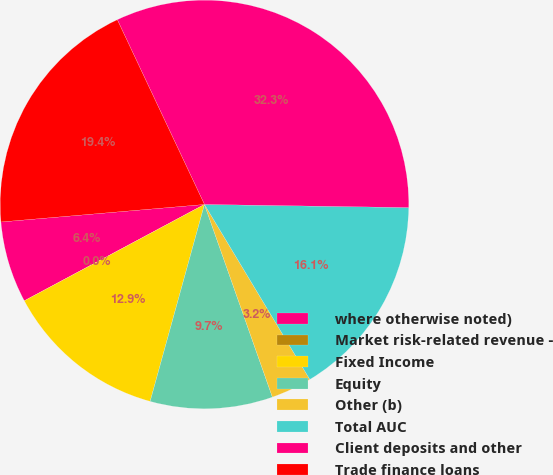Convert chart to OTSL. <chart><loc_0><loc_0><loc_500><loc_500><pie_chart><fcel>where otherwise noted)<fcel>Market risk-related revenue -<fcel>Fixed Income<fcel>Equity<fcel>Other (b)<fcel>Total AUC<fcel>Client deposits and other<fcel>Trade finance loans<nl><fcel>6.45%<fcel>0.0%<fcel>12.9%<fcel>9.68%<fcel>3.23%<fcel>16.13%<fcel>32.26%<fcel>19.35%<nl></chart> 